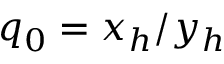<formula> <loc_0><loc_0><loc_500><loc_500>q _ { 0 } = x _ { h } / y _ { h }</formula> 